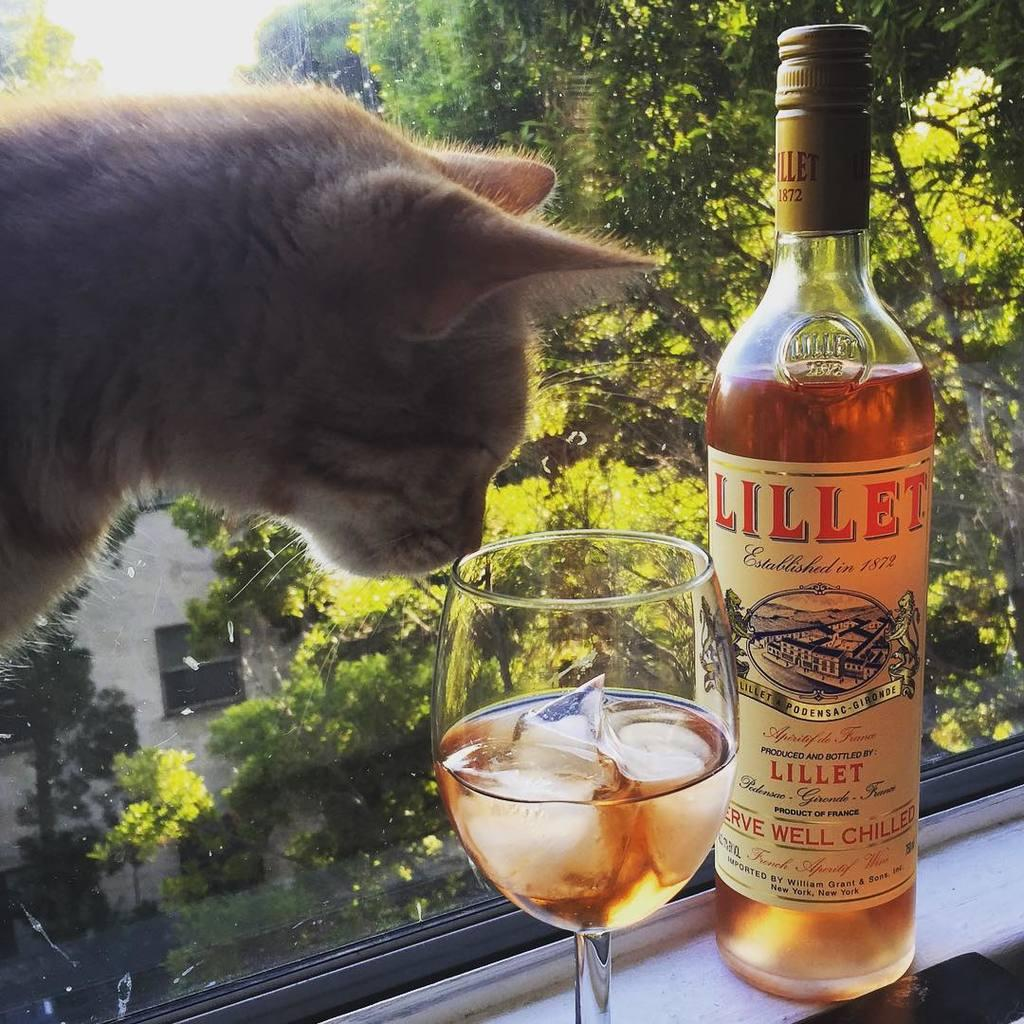<image>
Present a compact description of the photo's key features. A bottle of Lillet sits next to a glass with ice in it. 